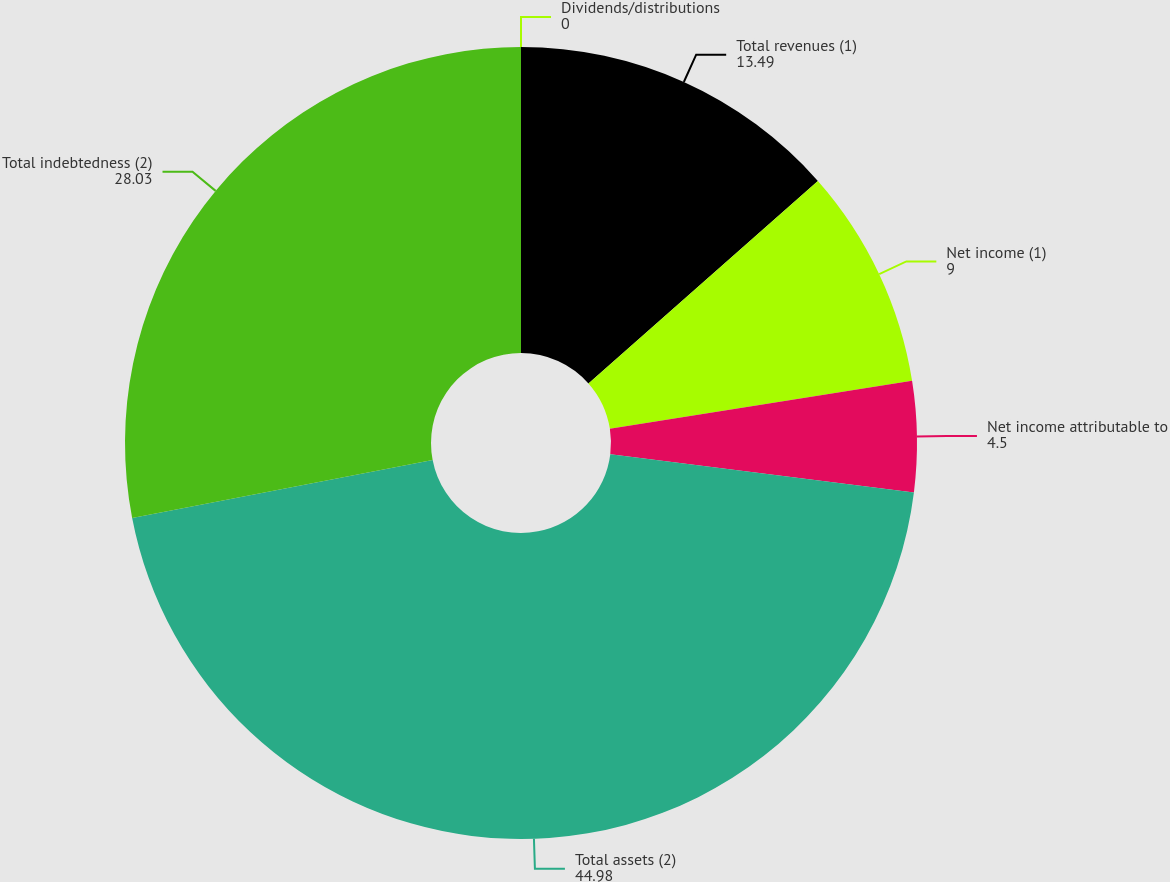Convert chart to OTSL. <chart><loc_0><loc_0><loc_500><loc_500><pie_chart><fcel>Total revenues (1)<fcel>Net income (1)<fcel>Net income attributable to<fcel>Total assets (2)<fcel>Total indebtedness (2)<fcel>Dividends/distributions<nl><fcel>13.49%<fcel>9.0%<fcel>4.5%<fcel>44.98%<fcel>28.03%<fcel>0.0%<nl></chart> 